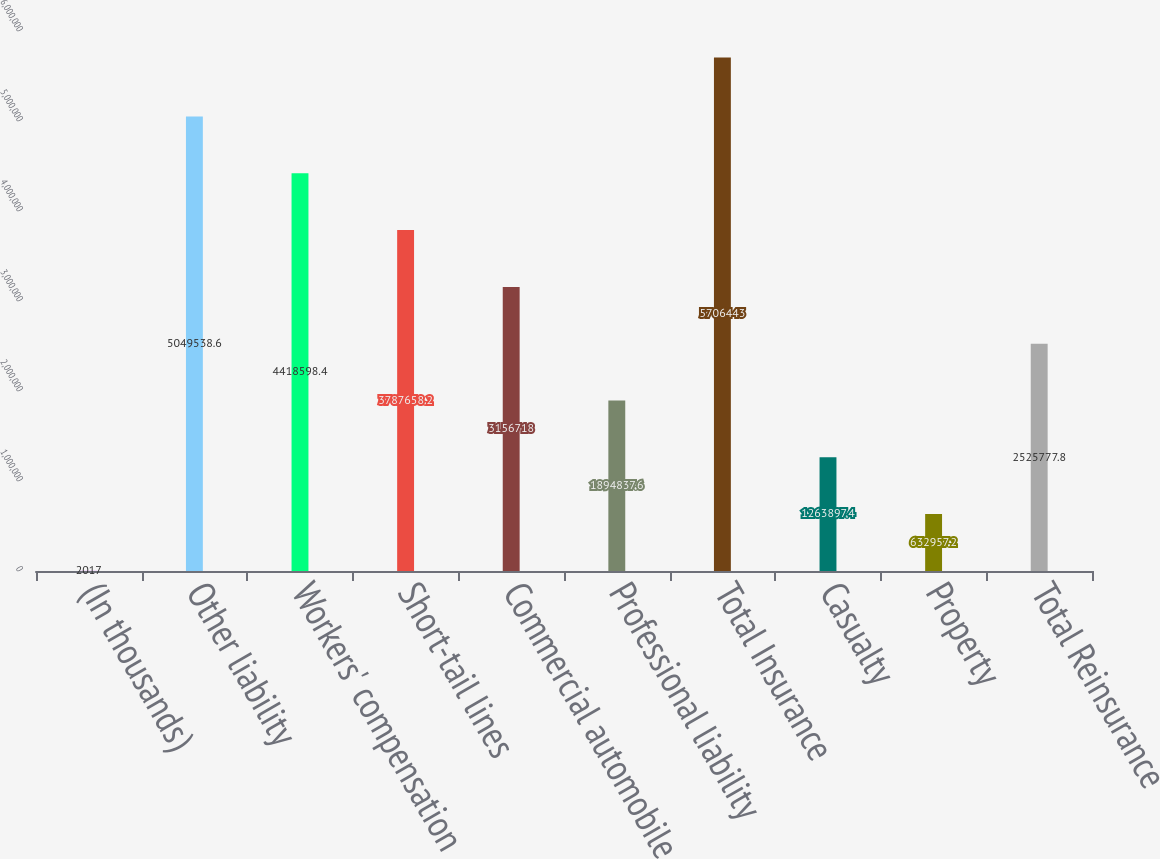Convert chart. <chart><loc_0><loc_0><loc_500><loc_500><bar_chart><fcel>(In thousands)<fcel>Other liability<fcel>Workers' compensation<fcel>Short-tail lines<fcel>Commercial automobile<fcel>Professional liability<fcel>Total Insurance<fcel>Casualty<fcel>Property<fcel>Total Reinsurance<nl><fcel>2017<fcel>5.04954e+06<fcel>4.4186e+06<fcel>3.78766e+06<fcel>3.15672e+06<fcel>1.89484e+06<fcel>5.70644e+06<fcel>1.2639e+06<fcel>632957<fcel>2.52578e+06<nl></chart> 